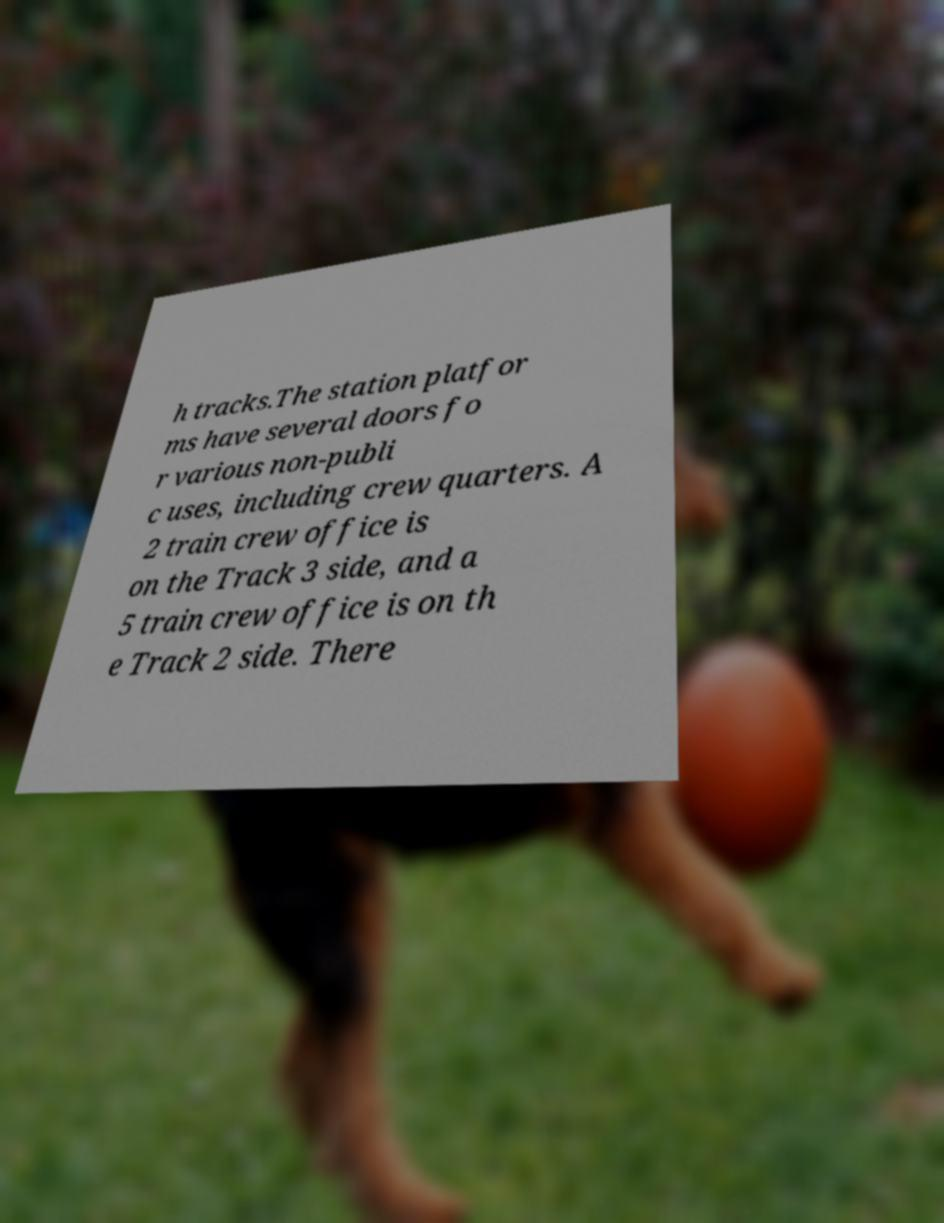Can you read and provide the text displayed in the image?This photo seems to have some interesting text. Can you extract and type it out for me? h tracks.The station platfor ms have several doors fo r various non-publi c uses, including crew quarters. A 2 train crew office is on the Track 3 side, and a 5 train crew office is on th e Track 2 side. There 